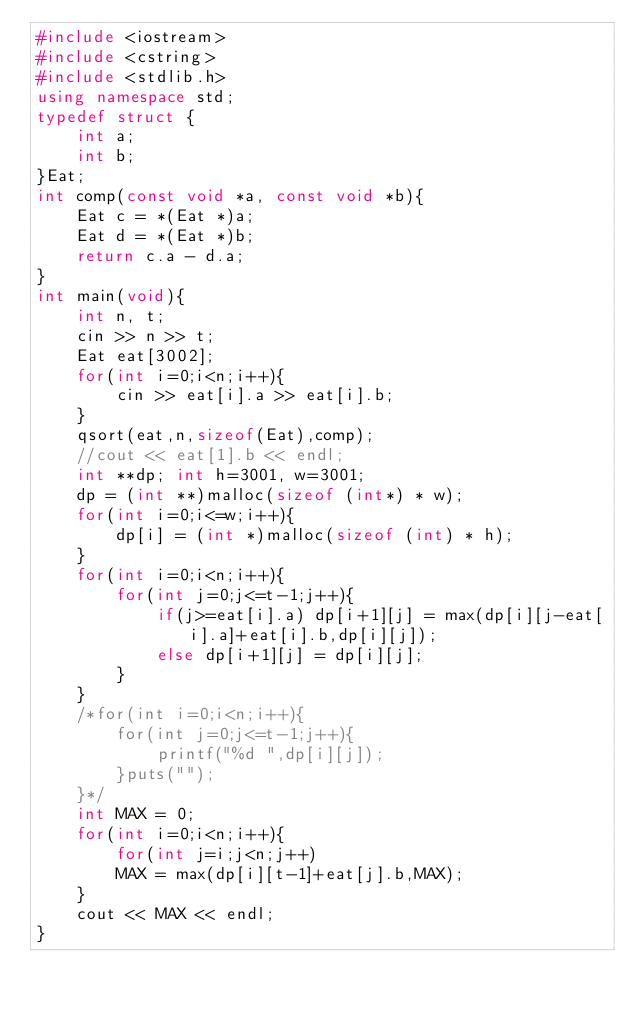Convert code to text. <code><loc_0><loc_0><loc_500><loc_500><_C++_>#include <iostream>
#include <cstring>
#include <stdlib.h>
using namespace std;
typedef struct {
    int a;
    int b;
}Eat;
int comp(const void *a, const void *b){
    Eat c = *(Eat *)a;
    Eat d = *(Eat *)b;
    return c.a - d.a;
}
int main(void){
    int n, t;
    cin >> n >> t;
    Eat eat[3002];
    for(int i=0;i<n;i++){
        cin >> eat[i].a >> eat[i].b;
    }
    qsort(eat,n,sizeof(Eat),comp);
    //cout << eat[1].b << endl;
    int **dp; int h=3001, w=3001;
    dp = (int **)malloc(sizeof (int*) * w);
    for(int i=0;i<=w;i++){
        dp[i] = (int *)malloc(sizeof (int) * h);
    }
    for(int i=0;i<n;i++){
        for(int j=0;j<=t-1;j++){
            if(j>=eat[i].a) dp[i+1][j] = max(dp[i][j-eat[i].a]+eat[i].b,dp[i][j]);
            else dp[i+1][j] = dp[i][j];
        }
    }
    /*for(int i=0;i<n;i++){
        for(int j=0;j<=t-1;j++){
            printf("%d ",dp[i][j]);
        }puts("");
    }*/
    int MAX = 0;
    for(int i=0;i<n;i++){
        for(int j=i;j<n;j++)
        MAX = max(dp[i][t-1]+eat[j].b,MAX);
    }
    cout << MAX << endl;
}
</code> 